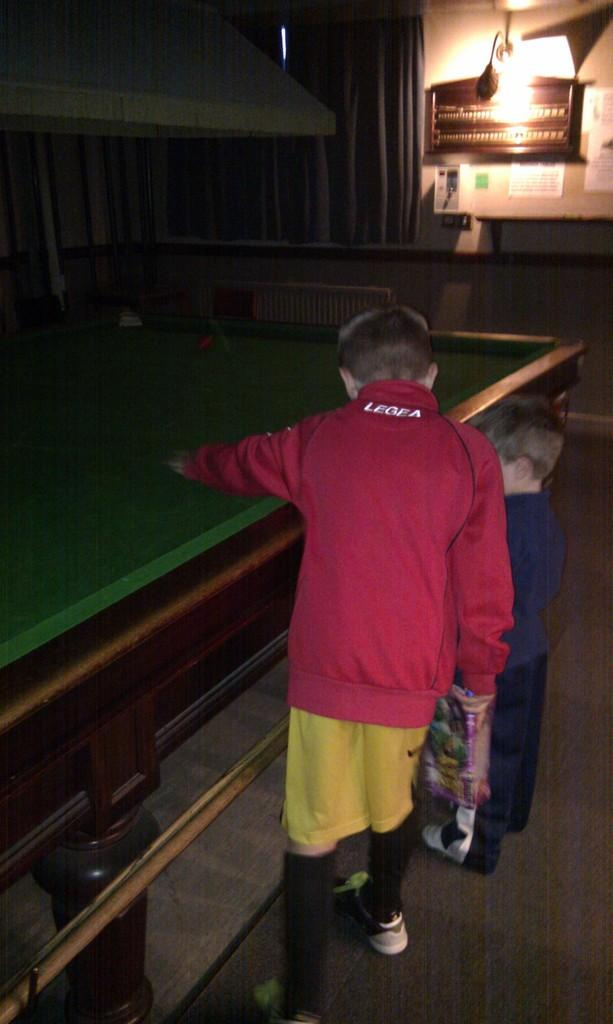How many children are present in the image? There are two children in the image. What is the position of the children in the image? The children are standing on the floor. What can be seen in the background of the image? The children are positioned near a snooker table. What type of work are the children engaged in during the summer in the image? There is no indication of work or summer in the image; it simply shows two children standing near a snooker table. What book is the child reading in the image? There is no book or reading activity present in the image. 